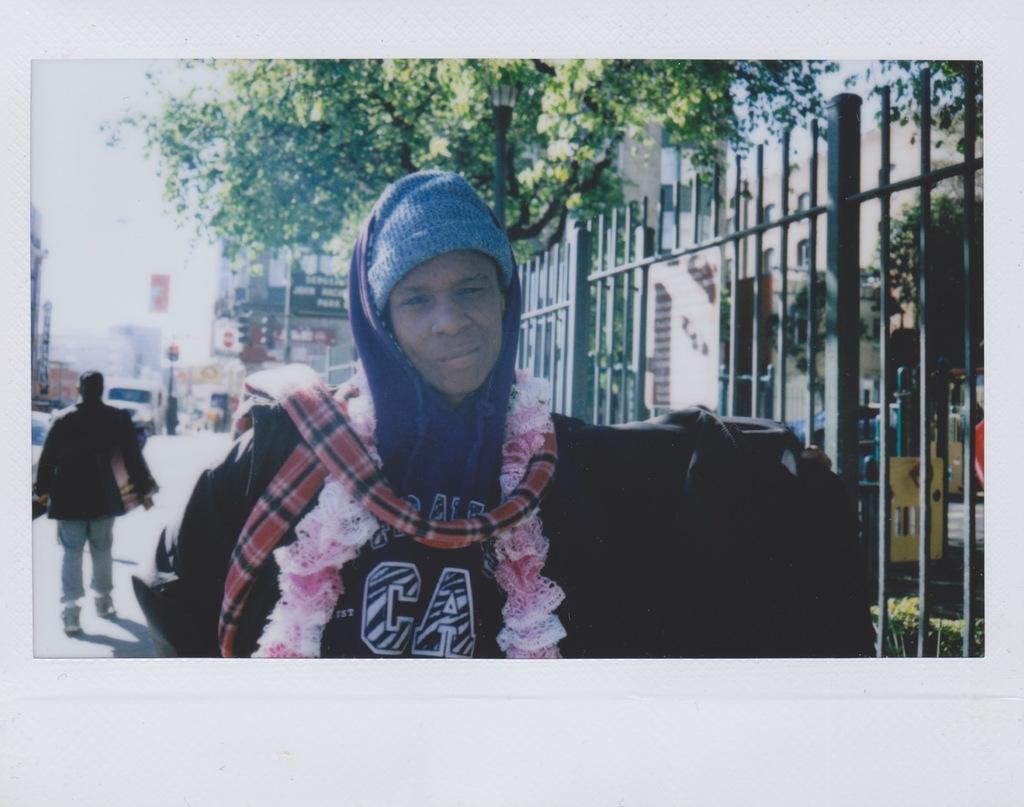What state abbreviation is displayed on the mans shirt?
Offer a terse response. Ca. 